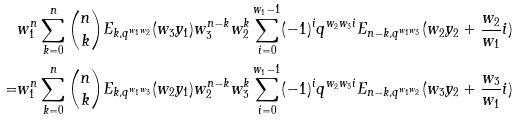<formula> <loc_0><loc_0><loc_500><loc_500>& w _ { 1 } ^ { n } \sum _ { k = 0 } ^ { n } \binom { n } { k } E _ { k , q ^ { w _ { 1 } w _ { 2 } } } ( w _ { 3 } y _ { 1 } ) w _ { 3 } ^ { n - k } w _ { 2 } ^ { k } \sum _ { i = 0 } ^ { w _ { 1 } - 1 } ( - 1 ) ^ { i } q ^ { w _ { 2 } w _ { 3 } i } E _ { n - k , q ^ { w _ { 1 } w _ { 3 } } } ( w _ { 2 } y _ { 2 } + \frac { w _ { 2 } } { w _ { 1 } } i ) \\ = & w _ { 1 } ^ { n } \sum _ { k = 0 } ^ { n } \binom { n } { k } E _ { k , q ^ { w _ { 1 } w _ { 3 } } } ( w _ { 2 } y _ { 1 } ) w _ { 2 } ^ { n - k } w _ { 3 } ^ { k } \sum _ { i = 0 } ^ { w _ { 1 } - 1 } ( - 1 ) ^ { i } q ^ { w _ { 2 } w _ { 3 } i } E _ { n - k , q ^ { w _ { 1 } w _ { 2 } } } ( w _ { 3 } y _ { 2 } + \frac { w _ { 3 } } { w _ { 1 } } i )</formula> 